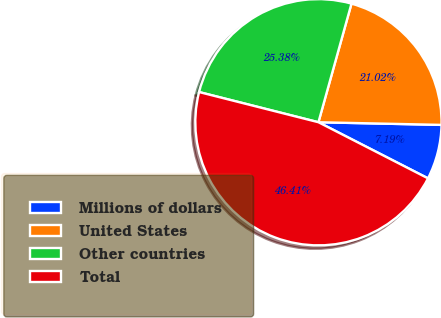<chart> <loc_0><loc_0><loc_500><loc_500><pie_chart><fcel>Millions of dollars<fcel>United States<fcel>Other countries<fcel>Total<nl><fcel>7.19%<fcel>21.02%<fcel>25.38%<fcel>46.41%<nl></chart> 